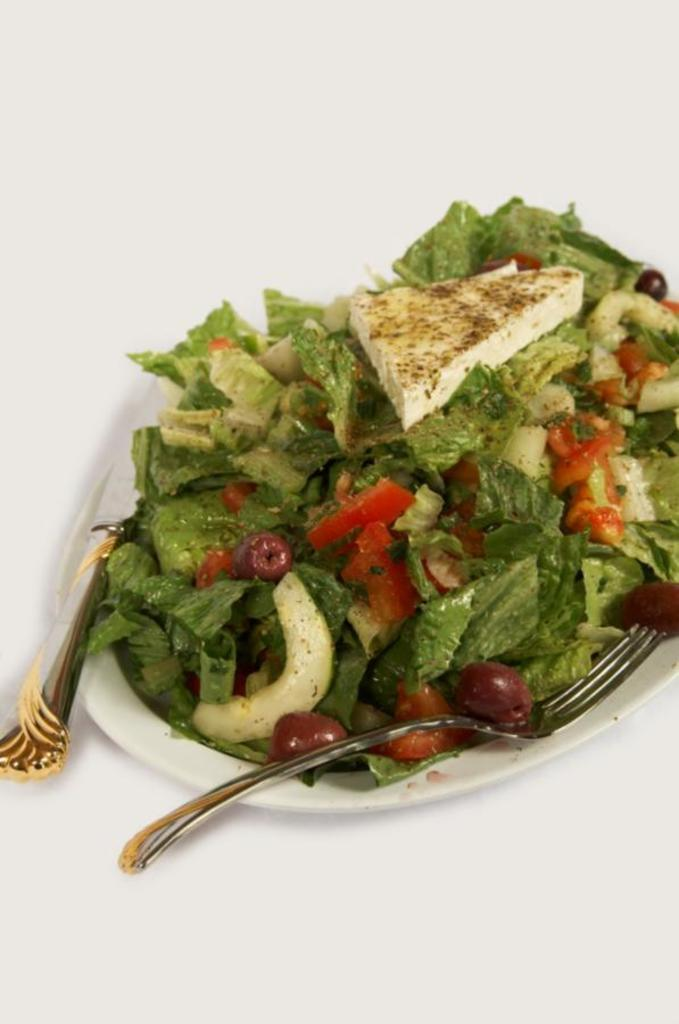What piece of furniture is present in the image? There is a table in the image. What type of food is on the table? There is a plate of salad on the table. What utensils are on the table? There is a knife and a fork on the table. How many chickens are present in the image? There are no chickens present in the image. What day of the week is depicted in the image? The day of the week is not depicted in the image. 